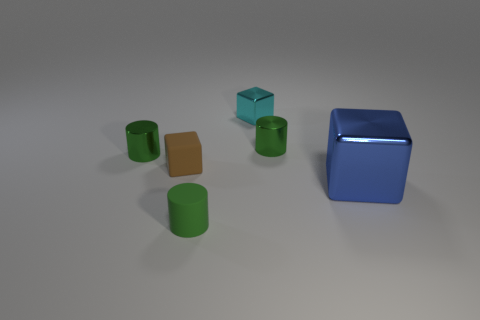Does the rubber cylinder have the same color as the small rubber object that is behind the big shiny thing?
Ensure brevity in your answer.  No. Are there any other small cubes of the same color as the small metal cube?
Your response must be concise. No. Is the large blue thing made of the same material as the small green cylinder that is to the right of the small green rubber object?
Provide a short and direct response. Yes. What number of large objects are either cyan shiny objects or green rubber objects?
Your answer should be very brief. 0. Is the number of red objects less than the number of small shiny cylinders?
Keep it short and to the point. Yes. Does the metal thing that is in front of the rubber cube have the same size as the green metallic cylinder that is right of the tiny cyan metal block?
Your answer should be very brief. No. How many brown things are either small shiny things or tiny shiny cylinders?
Your answer should be very brief. 0. Is the number of metal blocks greater than the number of small brown rubber blocks?
Make the answer very short. Yes. Is the color of the tiny rubber cylinder the same as the large metal cube?
Your answer should be very brief. No. How many objects are either big blue things or green cylinders that are in front of the blue thing?
Provide a short and direct response. 2. 